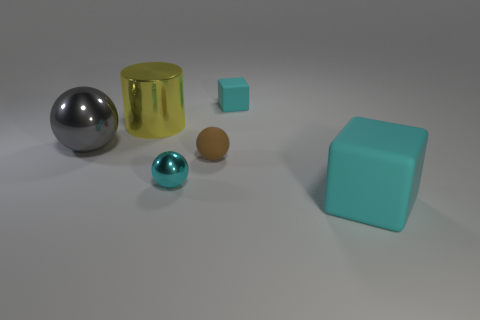Does the large cyan cube have the same material as the big object that is left of the big yellow object?
Provide a short and direct response. No. What is the color of the large rubber object?
Keep it short and to the point. Cyan. What is the color of the block that is behind the matte thing that is to the right of the cyan cube behind the tiny brown sphere?
Your answer should be compact. Cyan. Do the big cyan matte thing and the tiny cyan thing that is on the right side of the cyan sphere have the same shape?
Offer a very short reply. Yes. There is a object that is on the left side of the tiny cyan rubber object and in front of the brown object; what color is it?
Make the answer very short. Cyan. Is there a gray shiny thing of the same shape as the cyan metallic thing?
Your answer should be very brief. Yes. Do the large sphere and the large metal cylinder have the same color?
Provide a succinct answer. No. There is a small object that is behind the gray metal thing; are there any big objects right of it?
Provide a succinct answer. Yes. How many objects are big shiny things to the right of the gray ball or spheres in front of the gray object?
Offer a terse response. 3. How many objects are either big metal cubes or big objects that are behind the gray sphere?
Your response must be concise. 1. 